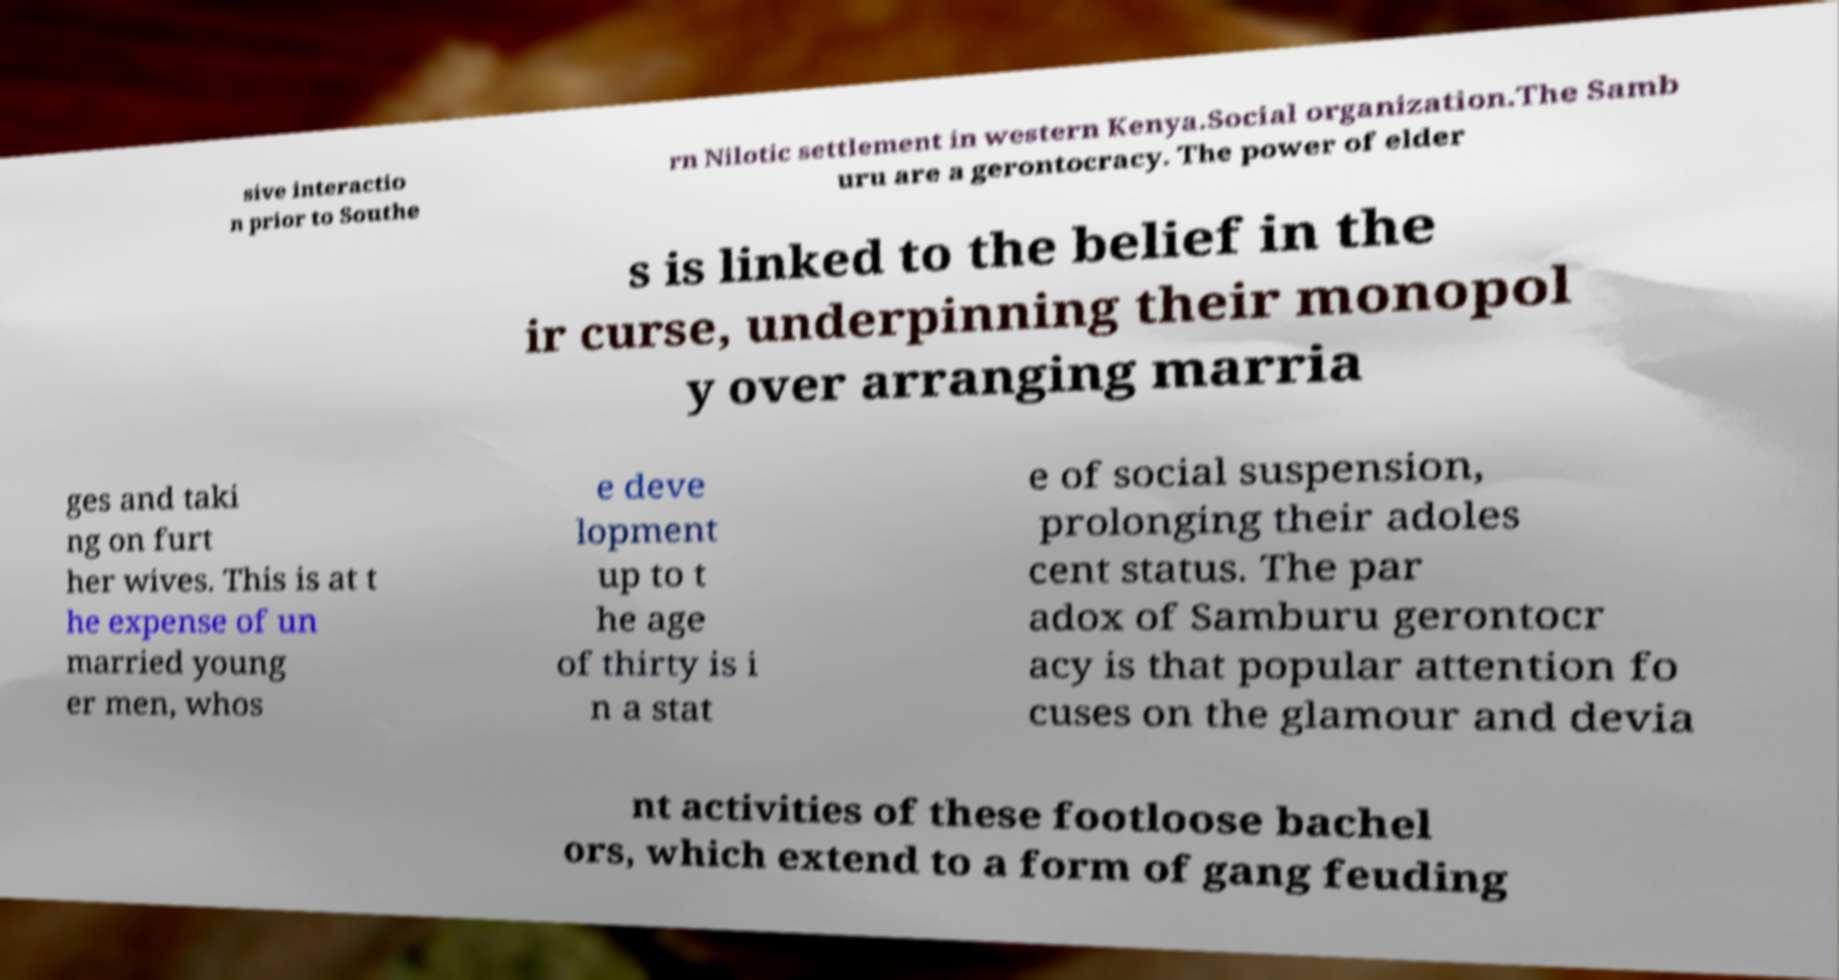Can you accurately transcribe the text from the provided image for me? sive interactio n prior to Southe rn Nilotic settlement in western Kenya.Social organization.The Samb uru are a gerontocracy. The power of elder s is linked to the belief in the ir curse, underpinning their monopol y over arranging marria ges and taki ng on furt her wives. This is at t he expense of un married young er men, whos e deve lopment up to t he age of thirty is i n a stat e of social suspension, prolonging their adoles cent status. The par adox of Samburu gerontocr acy is that popular attention fo cuses on the glamour and devia nt activities of these footloose bachel ors, which extend to a form of gang feuding 